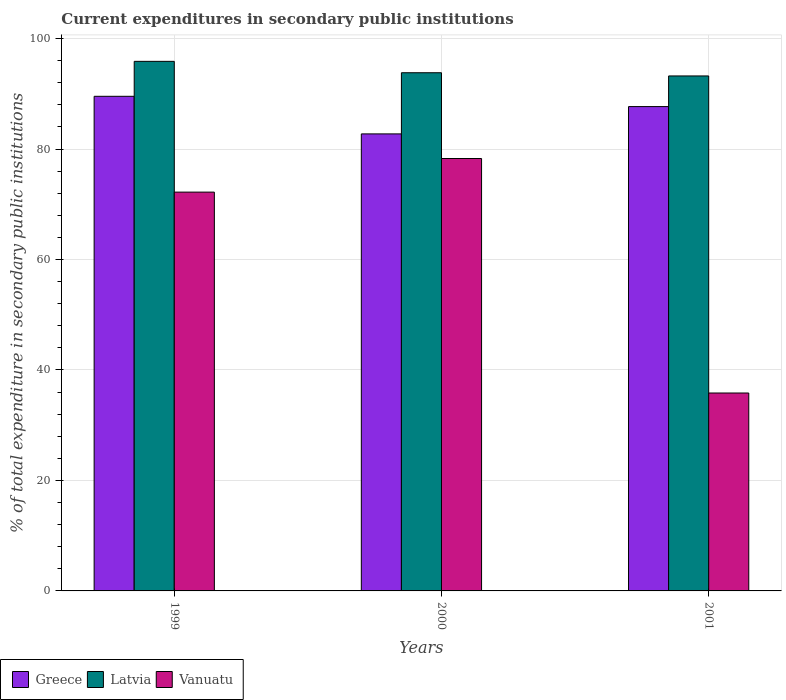Are the number of bars per tick equal to the number of legend labels?
Make the answer very short. Yes. What is the label of the 1st group of bars from the left?
Make the answer very short. 1999. What is the current expenditures in secondary public institutions in Latvia in 2000?
Offer a terse response. 93.82. Across all years, what is the maximum current expenditures in secondary public institutions in Vanuatu?
Make the answer very short. 78.29. Across all years, what is the minimum current expenditures in secondary public institutions in Greece?
Provide a succinct answer. 82.75. In which year was the current expenditures in secondary public institutions in Greece maximum?
Keep it short and to the point. 1999. What is the total current expenditures in secondary public institutions in Vanuatu in the graph?
Provide a succinct answer. 186.33. What is the difference between the current expenditures in secondary public institutions in Greece in 2000 and that in 2001?
Offer a very short reply. -4.94. What is the difference between the current expenditures in secondary public institutions in Greece in 2000 and the current expenditures in secondary public institutions in Latvia in 2001?
Offer a terse response. -10.49. What is the average current expenditures in secondary public institutions in Greece per year?
Provide a succinct answer. 86.66. In the year 1999, what is the difference between the current expenditures in secondary public institutions in Latvia and current expenditures in secondary public institutions in Vanuatu?
Offer a very short reply. 23.67. In how many years, is the current expenditures in secondary public institutions in Latvia greater than 52 %?
Give a very brief answer. 3. What is the ratio of the current expenditures in secondary public institutions in Greece in 1999 to that in 2001?
Give a very brief answer. 1.02. Is the current expenditures in secondary public institutions in Greece in 1999 less than that in 2000?
Give a very brief answer. No. Is the difference between the current expenditures in secondary public institutions in Latvia in 1999 and 2000 greater than the difference between the current expenditures in secondary public institutions in Vanuatu in 1999 and 2000?
Your answer should be very brief. Yes. What is the difference between the highest and the second highest current expenditures in secondary public institutions in Greece?
Provide a succinct answer. 1.86. What is the difference between the highest and the lowest current expenditures in secondary public institutions in Greece?
Offer a terse response. 6.81. In how many years, is the current expenditures in secondary public institutions in Vanuatu greater than the average current expenditures in secondary public institutions in Vanuatu taken over all years?
Ensure brevity in your answer.  2. Is the sum of the current expenditures in secondary public institutions in Latvia in 1999 and 2001 greater than the maximum current expenditures in secondary public institutions in Vanuatu across all years?
Give a very brief answer. Yes. What does the 1st bar from the left in 2001 represents?
Offer a very short reply. Greece. What does the 1st bar from the right in 2000 represents?
Offer a terse response. Vanuatu. Is it the case that in every year, the sum of the current expenditures in secondary public institutions in Vanuatu and current expenditures in secondary public institutions in Greece is greater than the current expenditures in secondary public institutions in Latvia?
Provide a succinct answer. Yes. How many years are there in the graph?
Make the answer very short. 3. What is the difference between two consecutive major ticks on the Y-axis?
Provide a succinct answer. 20. Does the graph contain any zero values?
Make the answer very short. No. How are the legend labels stacked?
Ensure brevity in your answer.  Horizontal. What is the title of the graph?
Your answer should be very brief. Current expenditures in secondary public institutions. Does "China" appear as one of the legend labels in the graph?
Keep it short and to the point. No. What is the label or title of the X-axis?
Your answer should be compact. Years. What is the label or title of the Y-axis?
Ensure brevity in your answer.  % of total expenditure in secondary public institutions. What is the % of total expenditure in secondary public institutions of Greece in 1999?
Your answer should be compact. 89.55. What is the % of total expenditure in secondary public institutions of Latvia in 1999?
Give a very brief answer. 95.88. What is the % of total expenditure in secondary public institutions of Vanuatu in 1999?
Keep it short and to the point. 72.21. What is the % of total expenditure in secondary public institutions of Greece in 2000?
Your answer should be very brief. 82.75. What is the % of total expenditure in secondary public institutions of Latvia in 2000?
Your answer should be very brief. 93.82. What is the % of total expenditure in secondary public institutions in Vanuatu in 2000?
Offer a very short reply. 78.29. What is the % of total expenditure in secondary public institutions in Greece in 2001?
Offer a terse response. 87.69. What is the % of total expenditure in secondary public institutions in Latvia in 2001?
Your answer should be very brief. 93.24. What is the % of total expenditure in secondary public institutions in Vanuatu in 2001?
Ensure brevity in your answer.  35.83. Across all years, what is the maximum % of total expenditure in secondary public institutions of Greece?
Keep it short and to the point. 89.55. Across all years, what is the maximum % of total expenditure in secondary public institutions in Latvia?
Your answer should be very brief. 95.88. Across all years, what is the maximum % of total expenditure in secondary public institutions in Vanuatu?
Make the answer very short. 78.29. Across all years, what is the minimum % of total expenditure in secondary public institutions in Greece?
Give a very brief answer. 82.75. Across all years, what is the minimum % of total expenditure in secondary public institutions in Latvia?
Give a very brief answer. 93.24. Across all years, what is the minimum % of total expenditure in secondary public institutions in Vanuatu?
Ensure brevity in your answer.  35.83. What is the total % of total expenditure in secondary public institutions in Greece in the graph?
Ensure brevity in your answer.  259.99. What is the total % of total expenditure in secondary public institutions of Latvia in the graph?
Ensure brevity in your answer.  282.94. What is the total % of total expenditure in secondary public institutions of Vanuatu in the graph?
Your answer should be compact. 186.33. What is the difference between the % of total expenditure in secondary public institutions of Greece in 1999 and that in 2000?
Your answer should be very brief. 6.81. What is the difference between the % of total expenditure in secondary public institutions of Latvia in 1999 and that in 2000?
Offer a terse response. 2.06. What is the difference between the % of total expenditure in secondary public institutions of Vanuatu in 1999 and that in 2000?
Your answer should be compact. -6.08. What is the difference between the % of total expenditure in secondary public institutions of Greece in 1999 and that in 2001?
Your response must be concise. 1.86. What is the difference between the % of total expenditure in secondary public institutions of Latvia in 1999 and that in 2001?
Make the answer very short. 2.64. What is the difference between the % of total expenditure in secondary public institutions in Vanuatu in 1999 and that in 2001?
Offer a terse response. 36.37. What is the difference between the % of total expenditure in secondary public institutions of Greece in 2000 and that in 2001?
Provide a succinct answer. -4.94. What is the difference between the % of total expenditure in secondary public institutions in Latvia in 2000 and that in 2001?
Ensure brevity in your answer.  0.58. What is the difference between the % of total expenditure in secondary public institutions of Vanuatu in 2000 and that in 2001?
Provide a succinct answer. 42.46. What is the difference between the % of total expenditure in secondary public institutions of Greece in 1999 and the % of total expenditure in secondary public institutions of Latvia in 2000?
Make the answer very short. -4.27. What is the difference between the % of total expenditure in secondary public institutions in Greece in 1999 and the % of total expenditure in secondary public institutions in Vanuatu in 2000?
Provide a succinct answer. 11.26. What is the difference between the % of total expenditure in secondary public institutions in Latvia in 1999 and the % of total expenditure in secondary public institutions in Vanuatu in 2000?
Offer a very short reply. 17.59. What is the difference between the % of total expenditure in secondary public institutions of Greece in 1999 and the % of total expenditure in secondary public institutions of Latvia in 2001?
Offer a very short reply. -3.69. What is the difference between the % of total expenditure in secondary public institutions of Greece in 1999 and the % of total expenditure in secondary public institutions of Vanuatu in 2001?
Make the answer very short. 53.72. What is the difference between the % of total expenditure in secondary public institutions in Latvia in 1999 and the % of total expenditure in secondary public institutions in Vanuatu in 2001?
Offer a very short reply. 60.05. What is the difference between the % of total expenditure in secondary public institutions in Greece in 2000 and the % of total expenditure in secondary public institutions in Latvia in 2001?
Make the answer very short. -10.49. What is the difference between the % of total expenditure in secondary public institutions in Greece in 2000 and the % of total expenditure in secondary public institutions in Vanuatu in 2001?
Offer a very short reply. 46.91. What is the difference between the % of total expenditure in secondary public institutions of Latvia in 2000 and the % of total expenditure in secondary public institutions of Vanuatu in 2001?
Offer a terse response. 57.99. What is the average % of total expenditure in secondary public institutions in Greece per year?
Keep it short and to the point. 86.66. What is the average % of total expenditure in secondary public institutions in Latvia per year?
Provide a short and direct response. 94.31. What is the average % of total expenditure in secondary public institutions in Vanuatu per year?
Offer a terse response. 62.11. In the year 1999, what is the difference between the % of total expenditure in secondary public institutions of Greece and % of total expenditure in secondary public institutions of Latvia?
Keep it short and to the point. -6.33. In the year 1999, what is the difference between the % of total expenditure in secondary public institutions in Greece and % of total expenditure in secondary public institutions in Vanuatu?
Your answer should be very brief. 17.35. In the year 1999, what is the difference between the % of total expenditure in secondary public institutions of Latvia and % of total expenditure in secondary public institutions of Vanuatu?
Give a very brief answer. 23.67. In the year 2000, what is the difference between the % of total expenditure in secondary public institutions of Greece and % of total expenditure in secondary public institutions of Latvia?
Your answer should be compact. -11.07. In the year 2000, what is the difference between the % of total expenditure in secondary public institutions in Greece and % of total expenditure in secondary public institutions in Vanuatu?
Keep it short and to the point. 4.46. In the year 2000, what is the difference between the % of total expenditure in secondary public institutions of Latvia and % of total expenditure in secondary public institutions of Vanuatu?
Your answer should be very brief. 15.53. In the year 2001, what is the difference between the % of total expenditure in secondary public institutions of Greece and % of total expenditure in secondary public institutions of Latvia?
Keep it short and to the point. -5.55. In the year 2001, what is the difference between the % of total expenditure in secondary public institutions of Greece and % of total expenditure in secondary public institutions of Vanuatu?
Provide a short and direct response. 51.86. In the year 2001, what is the difference between the % of total expenditure in secondary public institutions of Latvia and % of total expenditure in secondary public institutions of Vanuatu?
Your response must be concise. 57.4. What is the ratio of the % of total expenditure in secondary public institutions in Greece in 1999 to that in 2000?
Provide a succinct answer. 1.08. What is the ratio of the % of total expenditure in secondary public institutions in Latvia in 1999 to that in 2000?
Keep it short and to the point. 1.02. What is the ratio of the % of total expenditure in secondary public institutions of Vanuatu in 1999 to that in 2000?
Offer a terse response. 0.92. What is the ratio of the % of total expenditure in secondary public institutions in Greece in 1999 to that in 2001?
Offer a very short reply. 1.02. What is the ratio of the % of total expenditure in secondary public institutions of Latvia in 1999 to that in 2001?
Offer a very short reply. 1.03. What is the ratio of the % of total expenditure in secondary public institutions in Vanuatu in 1999 to that in 2001?
Provide a succinct answer. 2.02. What is the ratio of the % of total expenditure in secondary public institutions of Greece in 2000 to that in 2001?
Make the answer very short. 0.94. What is the ratio of the % of total expenditure in secondary public institutions of Latvia in 2000 to that in 2001?
Your answer should be very brief. 1.01. What is the ratio of the % of total expenditure in secondary public institutions of Vanuatu in 2000 to that in 2001?
Offer a terse response. 2.18. What is the difference between the highest and the second highest % of total expenditure in secondary public institutions of Greece?
Give a very brief answer. 1.86. What is the difference between the highest and the second highest % of total expenditure in secondary public institutions of Latvia?
Your response must be concise. 2.06. What is the difference between the highest and the second highest % of total expenditure in secondary public institutions in Vanuatu?
Provide a succinct answer. 6.08. What is the difference between the highest and the lowest % of total expenditure in secondary public institutions in Greece?
Your answer should be very brief. 6.81. What is the difference between the highest and the lowest % of total expenditure in secondary public institutions in Latvia?
Give a very brief answer. 2.64. What is the difference between the highest and the lowest % of total expenditure in secondary public institutions in Vanuatu?
Make the answer very short. 42.46. 